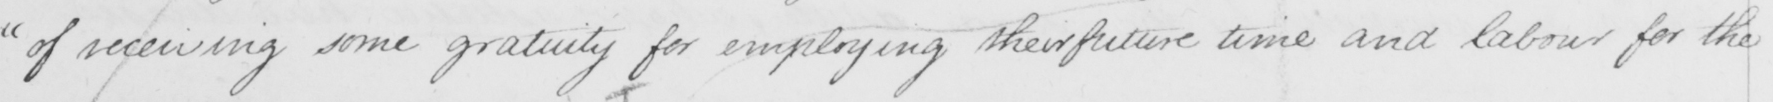Please transcribe the handwritten text in this image. of receiving some gratuity for employing their future time and labour for the 